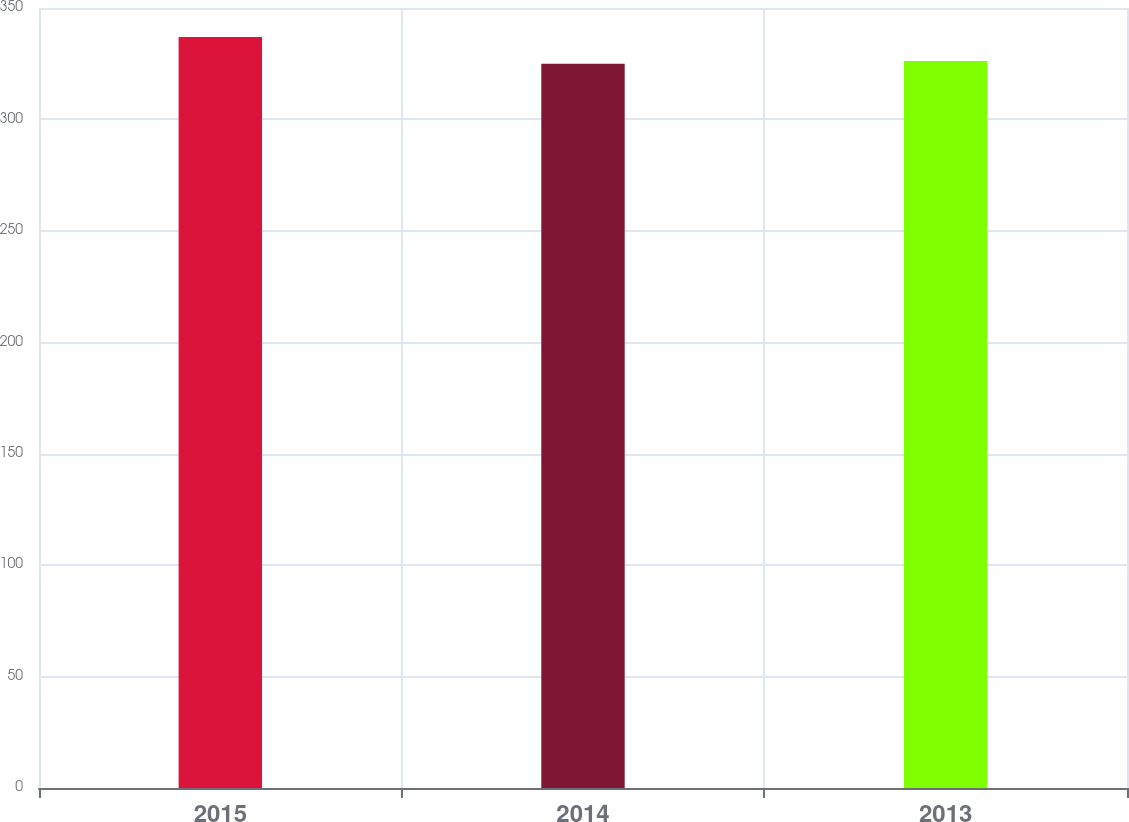Convert chart to OTSL. <chart><loc_0><loc_0><loc_500><loc_500><bar_chart><fcel>2015<fcel>2014<fcel>2013<nl><fcel>337<fcel>325<fcel>326.2<nl></chart> 